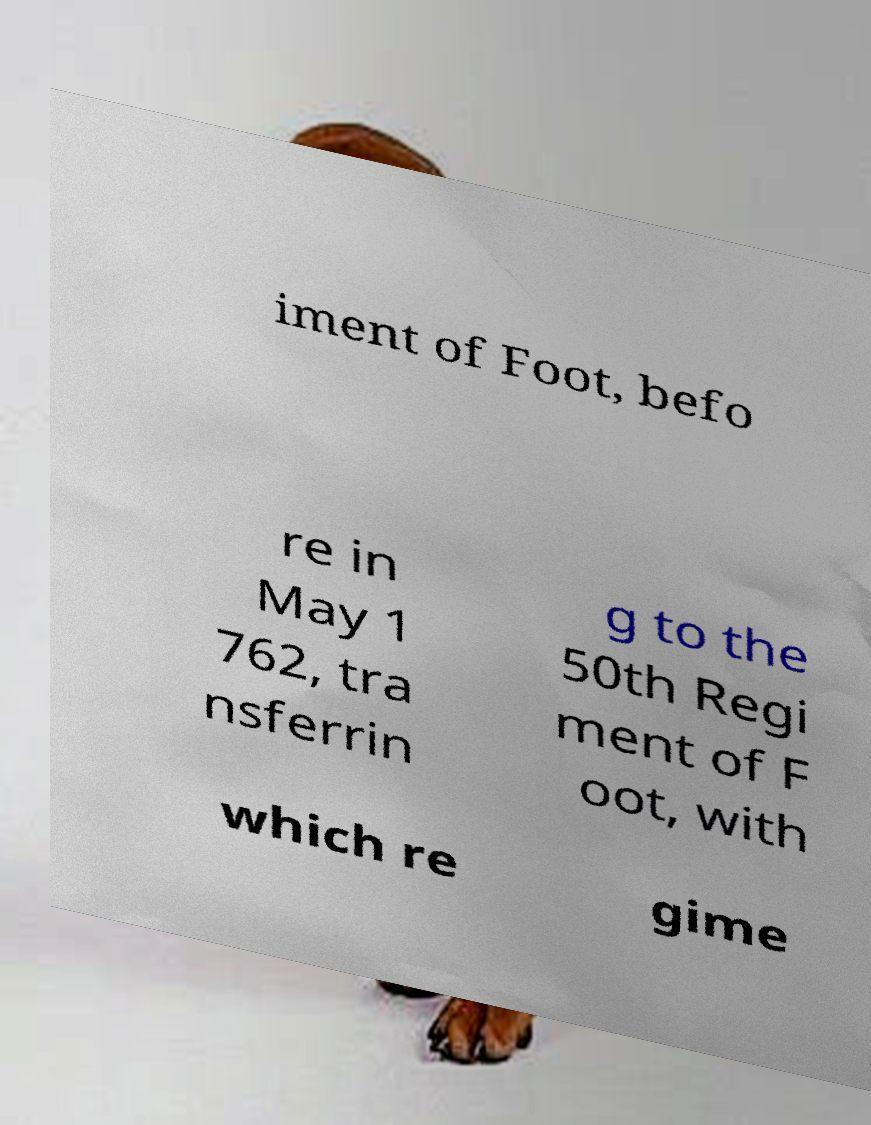Please identify and transcribe the text found in this image. iment of Foot, befo re in May 1 762, tra nsferrin g to the 50th Regi ment of F oot, with which re gime 